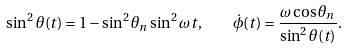<formula> <loc_0><loc_0><loc_500><loc_500>\sin ^ { 2 } \theta ( t ) = 1 - \sin ^ { 2 } \theta _ { n } \sin ^ { 2 } \omega t , \quad \dot { \phi } ( t ) = \frac { \omega \cos \theta _ { n } } { \sin ^ { 2 } \theta ( t ) } .</formula> 